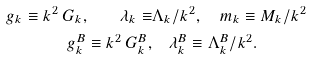Convert formula to latex. <formula><loc_0><loc_0><loc_500><loc_500>g _ { k } \equiv k ^ { 2 } \, G _ { k } , \quad \lambda _ { k } \equiv & \Lambda _ { k } / k ^ { 2 } , \quad m _ { k } \equiv M _ { k } / k ^ { 2 } \\ g _ { k } ^ { B } \equiv k ^ { 2 } \, G _ { k } ^ { B } , & \quad \lambda _ { k } ^ { B } \equiv \Lambda _ { k } ^ { B } / k ^ { 2 } .</formula> 